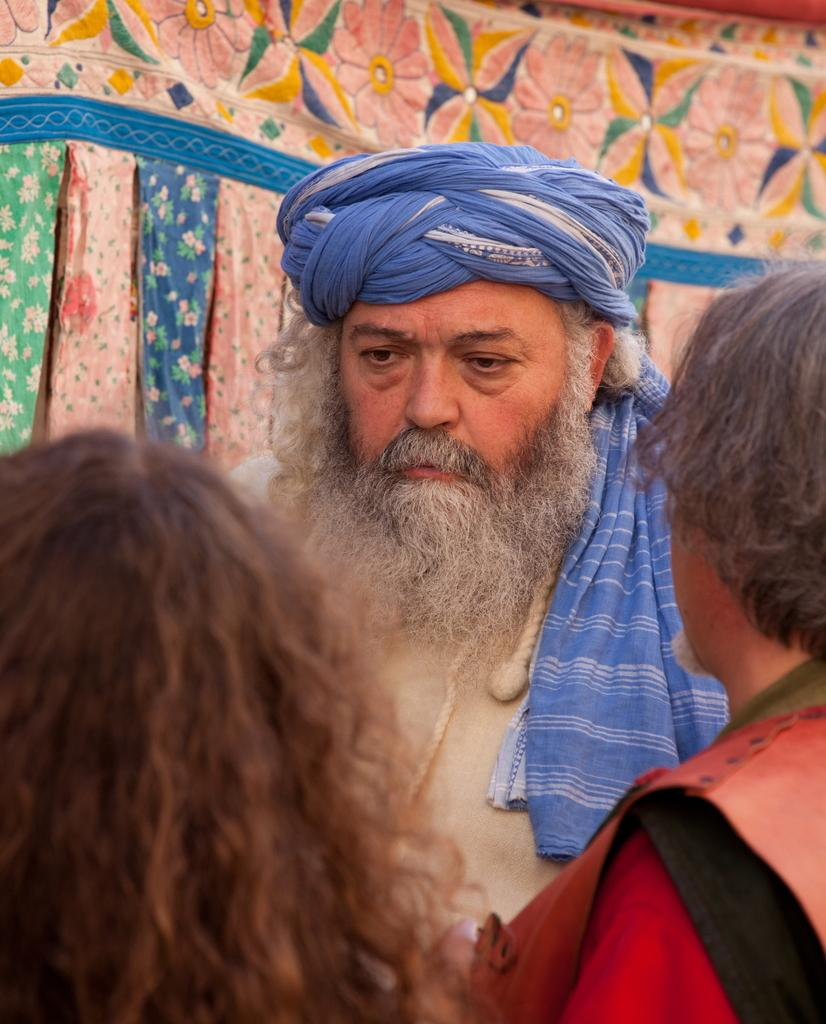How many people are in the image? There are three persons in the image. Can you describe the clothing of one of the persons? One person is wearing a turban. What can be seen in the background of the image? There is a cloth visible in the background of the image. What type of rings can be seen on the hands of the persons in the image? There are no rings visible on the hands of the persons in the image. How does the friction between the persons affect their interactions in the image? There is no indication of friction between the persons in the image, as they are not interacting with each other. 